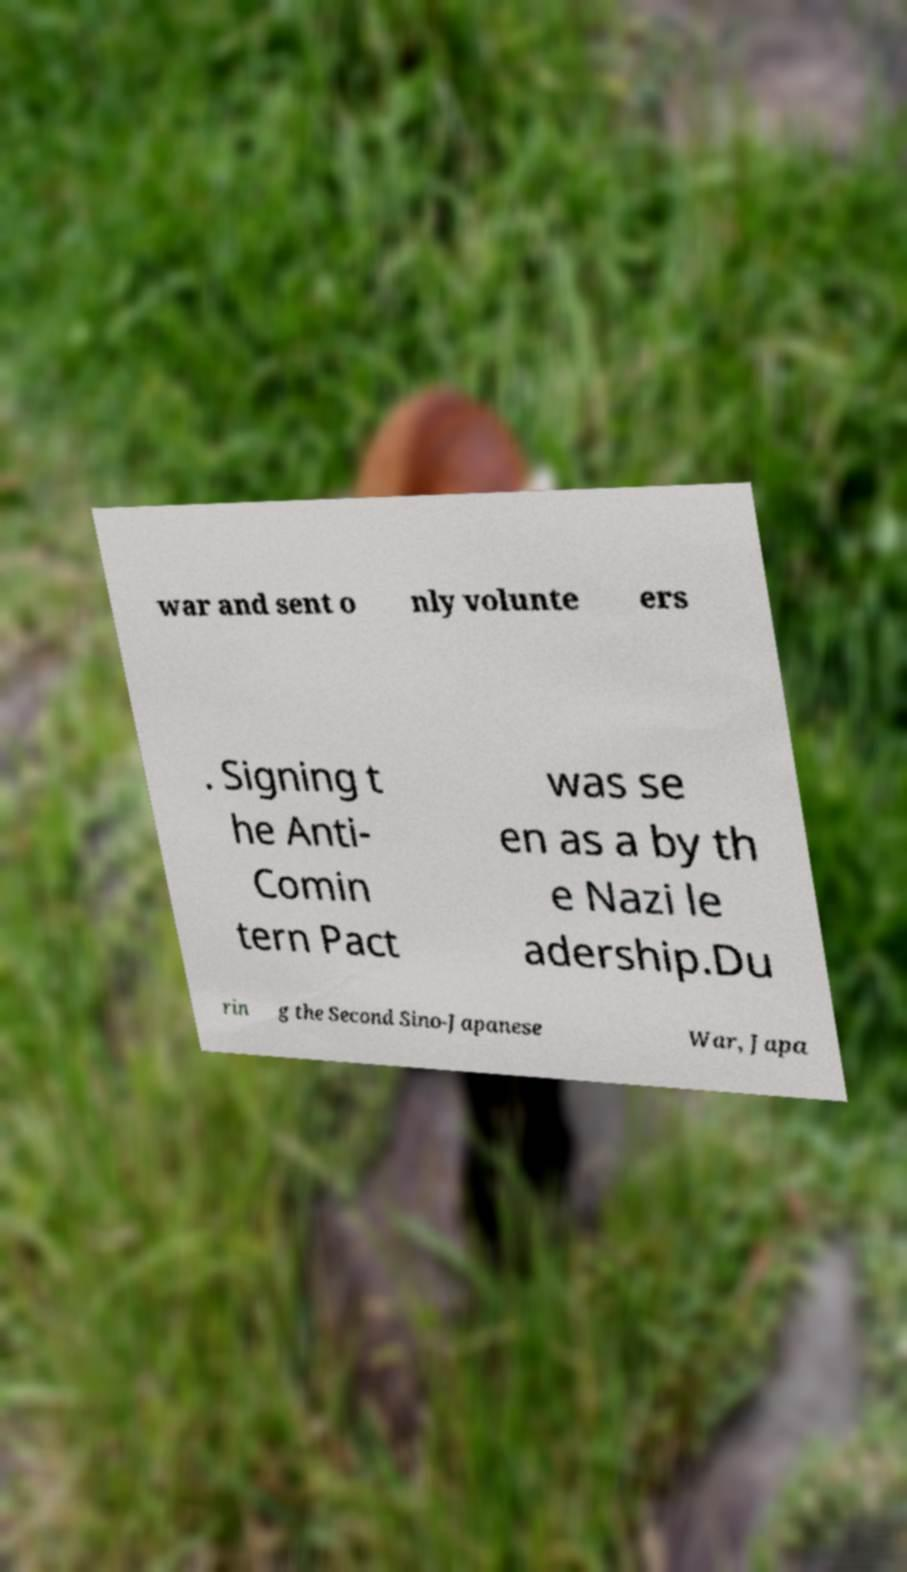For documentation purposes, I need the text within this image transcribed. Could you provide that? war and sent o nly volunte ers . Signing t he Anti- Comin tern Pact was se en as a by th e Nazi le adership.Du rin g the Second Sino-Japanese War, Japa 